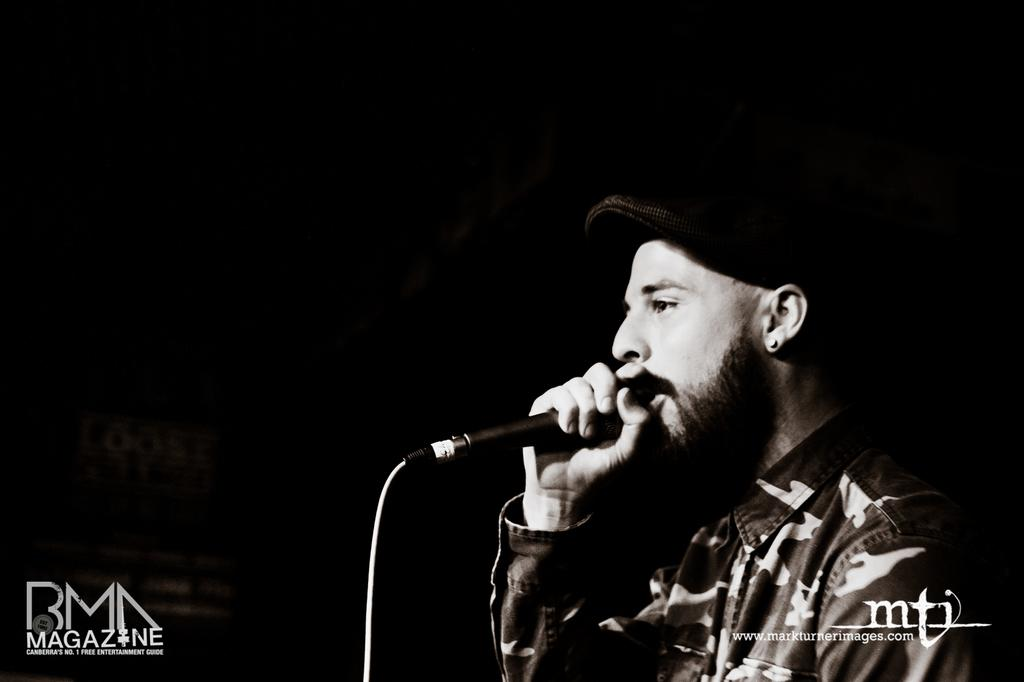Who or what is the main subject in the image? There is a person in the image. What is the person holding in the image? The person is holding a microphone. What is the person doing with the microphone? The person is speaking into the microphone. What design can be seen on the doll's dress in the image? There is no doll present in the image, so there is no doll's dress to describe. 